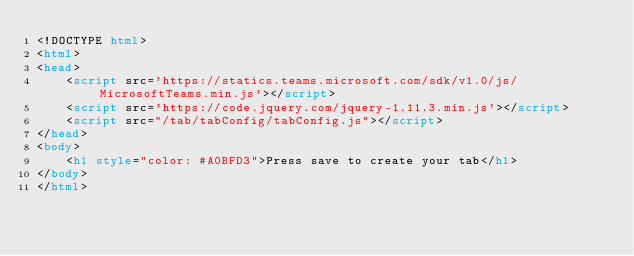<code> <loc_0><loc_0><loc_500><loc_500><_HTML_><!DOCTYPE html>
<html>
<head>
    <script src='https://statics.teams.microsoft.com/sdk/v1.0/js/MicrosoftTeams.min.js'></script>
    <script src='https://code.jquery.com/jquery-1.11.3.min.js'></script>
    <script src="/tab/tabConfig/tabConfig.js"></script>
</head>
<body>
    <h1 style="color: #A0BFD3">Press save to create your tab</h1> 
</body>   
</html>
</code> 